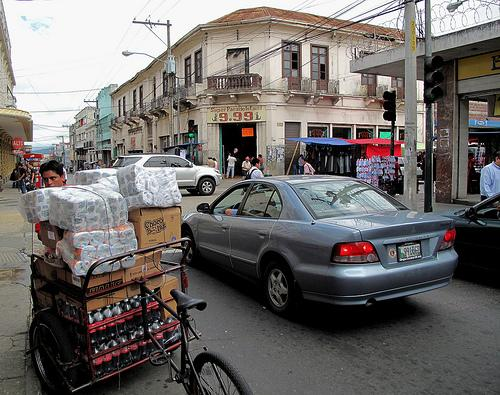What is the most noticeable element in the image and their activity? The prominent aspect is a man delivering supplies using a cart, accompanied by a black bicycle on a busy city street. Name the main character in the photo and describe their activity. The main character is a delivery man who is moving a cart filled with supplies and accompanied by a black bicycle on a busy street. Express the chief subject of the image and outline their doings. The chief subject of the image is a man engaged in delivering goods, who is pushing a cart and has a black bicycle for transportation. Mention the primary focus of the image and their action. A man is pushing a cart loaded with goods, including Coca Cola bottles, while standing behind his black delivery bike. Pinpoint the primary entity in the image and explain their behavior. The primary entity is a man handling a cart loaded with various items, including Coca Cola bottles, with a black bike for his delivery tasks. Discuss the leading element in the image and its significance. The leading element is a man carrying out deliveries using a cart filled with supplies and relying on a black bicycle to navigate through the city. Identify the key subject in the picture and detail their actions. The key subject is a man transporting goods using a cart, along with a black bicycle, as he delivers items across the city. Tell us about the prominent aspect of the image and what it entails. The prominent aspect involves a man pushing a cart loaded with goods, such as Coca Cola bottles, and having a black bike handy for deliveries. Identify the main object of attention in the photo and describe what it's doing. In the picture, the focal point is a man, who is pushing a loaded cart and has a black bicycle nearby for delivering goods. State the central figure in the image and elaborate on their actions. The central figure is a delivery man with a cart full of supplies, including Coca Cola bottles, and a black bike for delivering the items. 